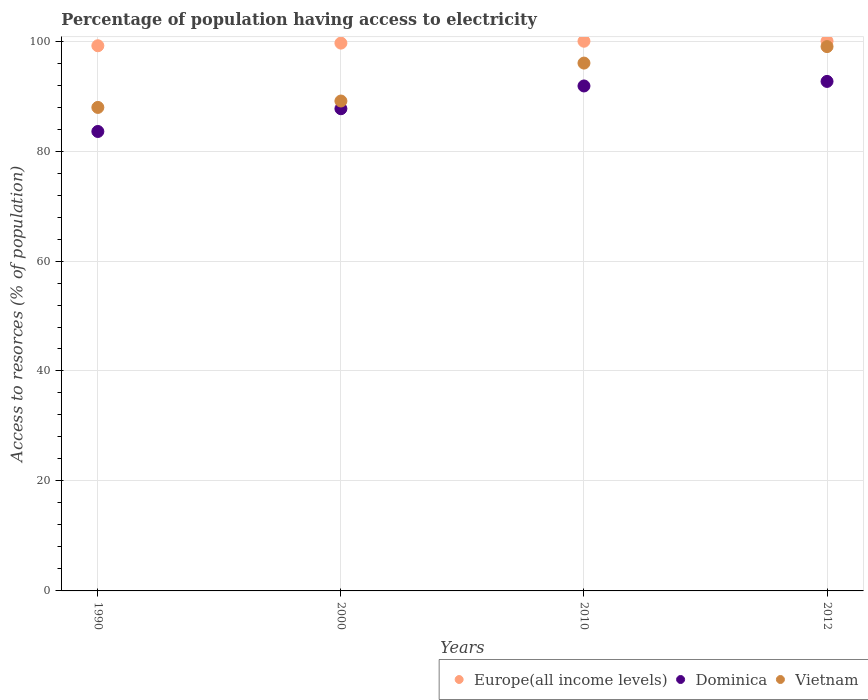How many different coloured dotlines are there?
Offer a very short reply. 3. What is the percentage of population having access to electricity in Dominica in 1990?
Make the answer very short. 83.56. Across all years, what is the minimum percentage of population having access to electricity in Europe(all income levels)?
Keep it short and to the point. 99.15. In which year was the percentage of population having access to electricity in Vietnam minimum?
Keep it short and to the point. 1990. What is the total percentage of population having access to electricity in Vietnam in the graph?
Offer a terse response. 372.04. What is the difference between the percentage of population having access to electricity in Vietnam in 2000 and that in 2012?
Provide a succinct answer. -9.9. What is the difference between the percentage of population having access to electricity in Europe(all income levels) in 2000 and the percentage of population having access to electricity in Vietnam in 2012?
Offer a terse response. 0.63. What is the average percentage of population having access to electricity in Dominica per year?
Offer a very short reply. 88.94. In the year 1990, what is the difference between the percentage of population having access to electricity in Dominica and percentage of population having access to electricity in Europe(all income levels)?
Provide a succinct answer. -15.59. What is the ratio of the percentage of population having access to electricity in Vietnam in 1990 to that in 2010?
Offer a terse response. 0.92. What is the difference between the highest and the second highest percentage of population having access to electricity in Europe(all income levels)?
Give a very brief answer. 0.03. What is the difference between the highest and the lowest percentage of population having access to electricity in Vietnam?
Your response must be concise. 11.06. In how many years, is the percentage of population having access to electricity in Vietnam greater than the average percentage of population having access to electricity in Vietnam taken over all years?
Give a very brief answer. 2. Is it the case that in every year, the sum of the percentage of population having access to electricity in Europe(all income levels) and percentage of population having access to electricity in Dominica  is greater than the percentage of population having access to electricity in Vietnam?
Your response must be concise. Yes. How many dotlines are there?
Keep it short and to the point. 3. How many years are there in the graph?
Give a very brief answer. 4. What is the difference between two consecutive major ticks on the Y-axis?
Provide a succinct answer. 20. Are the values on the major ticks of Y-axis written in scientific E-notation?
Give a very brief answer. No. Does the graph contain any zero values?
Give a very brief answer. No. Where does the legend appear in the graph?
Provide a succinct answer. Bottom right. How many legend labels are there?
Your answer should be compact. 3. How are the legend labels stacked?
Make the answer very short. Horizontal. What is the title of the graph?
Your response must be concise. Percentage of population having access to electricity. Does "Ecuador" appear as one of the legend labels in the graph?
Offer a terse response. No. What is the label or title of the X-axis?
Give a very brief answer. Years. What is the label or title of the Y-axis?
Give a very brief answer. Access to resorces (% of population). What is the Access to resorces (% of population) of Europe(all income levels) in 1990?
Provide a short and direct response. 99.15. What is the Access to resorces (% of population) of Dominica in 1990?
Give a very brief answer. 83.56. What is the Access to resorces (% of population) of Vietnam in 1990?
Keep it short and to the point. 87.94. What is the Access to resorces (% of population) of Europe(all income levels) in 2000?
Ensure brevity in your answer.  99.63. What is the Access to resorces (% of population) of Dominica in 2000?
Give a very brief answer. 87.7. What is the Access to resorces (% of population) in Vietnam in 2000?
Offer a terse response. 89.1. What is the Access to resorces (% of population) of Europe(all income levels) in 2010?
Keep it short and to the point. 99.97. What is the Access to resorces (% of population) of Dominica in 2010?
Offer a very short reply. 91.84. What is the Access to resorces (% of population) in Vietnam in 2010?
Your answer should be very brief. 96. What is the Access to resorces (% of population) in Dominica in 2012?
Give a very brief answer. 92.67. Across all years, what is the maximum Access to resorces (% of population) of Europe(all income levels)?
Your answer should be very brief. 100. Across all years, what is the maximum Access to resorces (% of population) of Dominica?
Provide a short and direct response. 92.67. Across all years, what is the minimum Access to resorces (% of population) in Europe(all income levels)?
Your answer should be very brief. 99.15. Across all years, what is the minimum Access to resorces (% of population) of Dominica?
Your response must be concise. 83.56. Across all years, what is the minimum Access to resorces (% of population) of Vietnam?
Make the answer very short. 87.94. What is the total Access to resorces (% of population) of Europe(all income levels) in the graph?
Ensure brevity in your answer.  398.76. What is the total Access to resorces (% of population) in Dominica in the graph?
Provide a succinct answer. 355.77. What is the total Access to resorces (% of population) in Vietnam in the graph?
Make the answer very short. 372.04. What is the difference between the Access to resorces (% of population) in Europe(all income levels) in 1990 and that in 2000?
Make the answer very short. -0.48. What is the difference between the Access to resorces (% of population) of Dominica in 1990 and that in 2000?
Give a very brief answer. -4.14. What is the difference between the Access to resorces (% of population) of Vietnam in 1990 and that in 2000?
Your answer should be compact. -1.16. What is the difference between the Access to resorces (% of population) of Europe(all income levels) in 1990 and that in 2010?
Ensure brevity in your answer.  -0.82. What is the difference between the Access to resorces (% of population) of Dominica in 1990 and that in 2010?
Your response must be concise. -8.28. What is the difference between the Access to resorces (% of population) in Vietnam in 1990 and that in 2010?
Give a very brief answer. -8.06. What is the difference between the Access to resorces (% of population) in Europe(all income levels) in 1990 and that in 2012?
Offer a terse response. -0.85. What is the difference between the Access to resorces (% of population) of Dominica in 1990 and that in 2012?
Provide a short and direct response. -9.11. What is the difference between the Access to resorces (% of population) of Vietnam in 1990 and that in 2012?
Give a very brief answer. -11.06. What is the difference between the Access to resorces (% of population) of Europe(all income levels) in 2000 and that in 2010?
Provide a succinct answer. -0.34. What is the difference between the Access to resorces (% of population) of Dominica in 2000 and that in 2010?
Make the answer very short. -4.14. What is the difference between the Access to resorces (% of population) of Vietnam in 2000 and that in 2010?
Offer a very short reply. -6.9. What is the difference between the Access to resorces (% of population) of Europe(all income levels) in 2000 and that in 2012?
Offer a very short reply. -0.37. What is the difference between the Access to resorces (% of population) in Dominica in 2000 and that in 2012?
Make the answer very short. -4.97. What is the difference between the Access to resorces (% of population) of Europe(all income levels) in 2010 and that in 2012?
Your answer should be compact. -0.03. What is the difference between the Access to resorces (% of population) in Dominica in 2010 and that in 2012?
Ensure brevity in your answer.  -0.83. What is the difference between the Access to resorces (% of population) of Europe(all income levels) in 1990 and the Access to resorces (% of population) of Dominica in 2000?
Keep it short and to the point. 11.45. What is the difference between the Access to resorces (% of population) of Europe(all income levels) in 1990 and the Access to resorces (% of population) of Vietnam in 2000?
Your answer should be compact. 10.05. What is the difference between the Access to resorces (% of population) of Dominica in 1990 and the Access to resorces (% of population) of Vietnam in 2000?
Offer a very short reply. -5.54. What is the difference between the Access to resorces (% of population) of Europe(all income levels) in 1990 and the Access to resorces (% of population) of Dominica in 2010?
Your answer should be very brief. 7.31. What is the difference between the Access to resorces (% of population) of Europe(all income levels) in 1990 and the Access to resorces (% of population) of Vietnam in 2010?
Offer a terse response. 3.15. What is the difference between the Access to resorces (% of population) in Dominica in 1990 and the Access to resorces (% of population) in Vietnam in 2010?
Offer a terse response. -12.44. What is the difference between the Access to resorces (% of population) of Europe(all income levels) in 1990 and the Access to resorces (% of population) of Dominica in 2012?
Provide a short and direct response. 6.49. What is the difference between the Access to resorces (% of population) in Europe(all income levels) in 1990 and the Access to resorces (% of population) in Vietnam in 2012?
Offer a very short reply. 0.15. What is the difference between the Access to resorces (% of population) in Dominica in 1990 and the Access to resorces (% of population) in Vietnam in 2012?
Ensure brevity in your answer.  -15.44. What is the difference between the Access to resorces (% of population) of Europe(all income levels) in 2000 and the Access to resorces (% of population) of Dominica in 2010?
Give a very brief answer. 7.79. What is the difference between the Access to resorces (% of population) of Europe(all income levels) in 2000 and the Access to resorces (% of population) of Vietnam in 2010?
Offer a terse response. 3.63. What is the difference between the Access to resorces (% of population) of Dominica in 2000 and the Access to resorces (% of population) of Vietnam in 2010?
Keep it short and to the point. -8.3. What is the difference between the Access to resorces (% of population) in Europe(all income levels) in 2000 and the Access to resorces (% of population) in Dominica in 2012?
Your response must be concise. 6.97. What is the difference between the Access to resorces (% of population) of Europe(all income levels) in 2000 and the Access to resorces (% of population) of Vietnam in 2012?
Your response must be concise. 0.63. What is the difference between the Access to resorces (% of population) of Europe(all income levels) in 2010 and the Access to resorces (% of population) of Dominica in 2012?
Offer a very short reply. 7.31. What is the difference between the Access to resorces (% of population) of Europe(all income levels) in 2010 and the Access to resorces (% of population) of Vietnam in 2012?
Offer a very short reply. 0.97. What is the difference between the Access to resorces (% of population) of Dominica in 2010 and the Access to resorces (% of population) of Vietnam in 2012?
Keep it short and to the point. -7.16. What is the average Access to resorces (% of population) in Europe(all income levels) per year?
Offer a terse response. 99.69. What is the average Access to resorces (% of population) of Dominica per year?
Ensure brevity in your answer.  88.94. What is the average Access to resorces (% of population) in Vietnam per year?
Ensure brevity in your answer.  93.01. In the year 1990, what is the difference between the Access to resorces (% of population) of Europe(all income levels) and Access to resorces (% of population) of Dominica?
Make the answer very short. 15.59. In the year 1990, what is the difference between the Access to resorces (% of population) in Europe(all income levels) and Access to resorces (% of population) in Vietnam?
Offer a terse response. 11.22. In the year 1990, what is the difference between the Access to resorces (% of population) of Dominica and Access to resorces (% of population) of Vietnam?
Offer a terse response. -4.38. In the year 2000, what is the difference between the Access to resorces (% of population) in Europe(all income levels) and Access to resorces (% of population) in Dominica?
Keep it short and to the point. 11.93. In the year 2000, what is the difference between the Access to resorces (% of population) of Europe(all income levels) and Access to resorces (% of population) of Vietnam?
Your response must be concise. 10.53. In the year 2000, what is the difference between the Access to resorces (% of population) of Dominica and Access to resorces (% of population) of Vietnam?
Your answer should be compact. -1.4. In the year 2010, what is the difference between the Access to resorces (% of population) of Europe(all income levels) and Access to resorces (% of population) of Dominica?
Ensure brevity in your answer.  8.14. In the year 2010, what is the difference between the Access to resorces (% of population) of Europe(all income levels) and Access to resorces (% of population) of Vietnam?
Your response must be concise. 3.97. In the year 2010, what is the difference between the Access to resorces (% of population) of Dominica and Access to resorces (% of population) of Vietnam?
Give a very brief answer. -4.16. In the year 2012, what is the difference between the Access to resorces (% of population) of Europe(all income levels) and Access to resorces (% of population) of Dominica?
Provide a short and direct response. 7.33. In the year 2012, what is the difference between the Access to resorces (% of population) in Europe(all income levels) and Access to resorces (% of population) in Vietnam?
Give a very brief answer. 1. In the year 2012, what is the difference between the Access to resorces (% of population) of Dominica and Access to resorces (% of population) of Vietnam?
Keep it short and to the point. -6.33. What is the ratio of the Access to resorces (% of population) of Europe(all income levels) in 1990 to that in 2000?
Your answer should be compact. 1. What is the ratio of the Access to resorces (% of population) in Dominica in 1990 to that in 2000?
Offer a terse response. 0.95. What is the ratio of the Access to resorces (% of population) of Dominica in 1990 to that in 2010?
Keep it short and to the point. 0.91. What is the ratio of the Access to resorces (% of population) of Vietnam in 1990 to that in 2010?
Offer a terse response. 0.92. What is the ratio of the Access to resorces (% of population) of Europe(all income levels) in 1990 to that in 2012?
Provide a succinct answer. 0.99. What is the ratio of the Access to resorces (% of population) of Dominica in 1990 to that in 2012?
Ensure brevity in your answer.  0.9. What is the ratio of the Access to resorces (% of population) in Vietnam in 1990 to that in 2012?
Offer a terse response. 0.89. What is the ratio of the Access to resorces (% of population) of Dominica in 2000 to that in 2010?
Ensure brevity in your answer.  0.95. What is the ratio of the Access to resorces (% of population) in Vietnam in 2000 to that in 2010?
Your answer should be compact. 0.93. What is the ratio of the Access to resorces (% of population) of Dominica in 2000 to that in 2012?
Your answer should be very brief. 0.95. What is the ratio of the Access to resorces (% of population) in Europe(all income levels) in 2010 to that in 2012?
Your answer should be compact. 1. What is the ratio of the Access to resorces (% of population) in Dominica in 2010 to that in 2012?
Ensure brevity in your answer.  0.99. What is the ratio of the Access to resorces (% of population) of Vietnam in 2010 to that in 2012?
Provide a short and direct response. 0.97. What is the difference between the highest and the second highest Access to resorces (% of population) in Europe(all income levels)?
Your answer should be compact. 0.03. What is the difference between the highest and the second highest Access to resorces (% of population) in Dominica?
Provide a short and direct response. 0.83. What is the difference between the highest and the lowest Access to resorces (% of population) of Europe(all income levels)?
Your response must be concise. 0.85. What is the difference between the highest and the lowest Access to resorces (% of population) in Dominica?
Your answer should be compact. 9.11. What is the difference between the highest and the lowest Access to resorces (% of population) of Vietnam?
Make the answer very short. 11.06. 